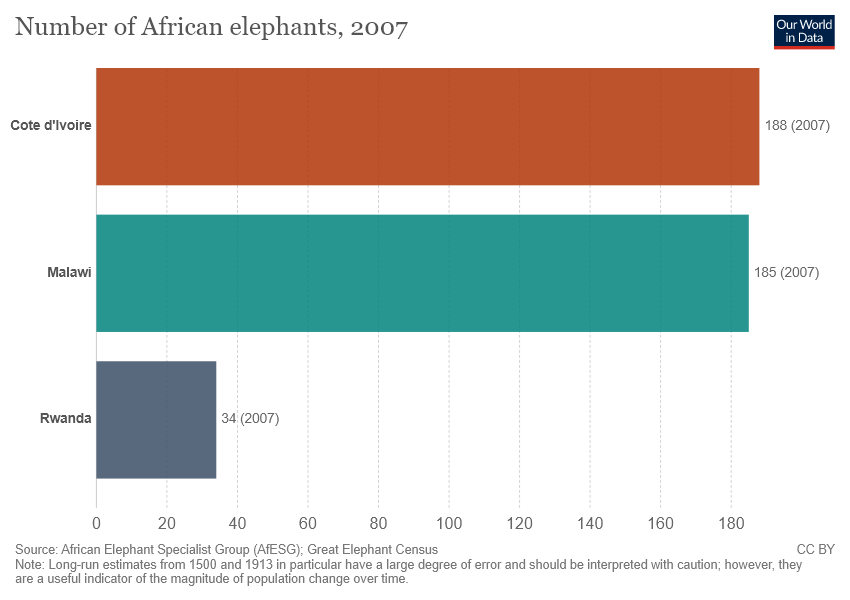List a handful of essential elements in this visual. The color of the largest bar is brown. The total sum of all the bars is 407. 